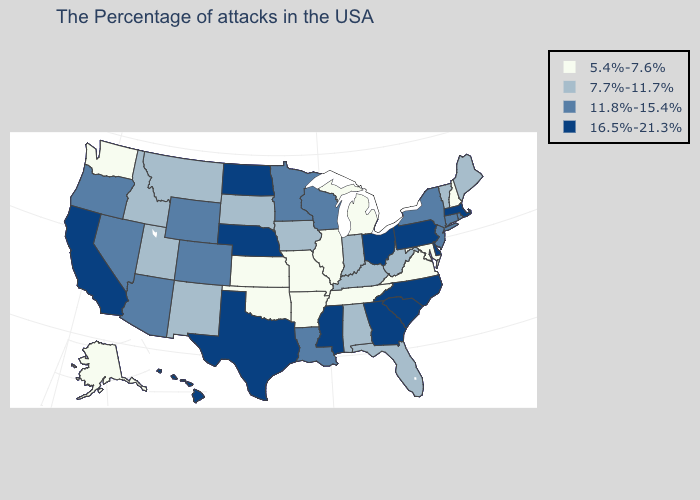Does Alaska have the lowest value in the West?
Give a very brief answer. Yes. Does the first symbol in the legend represent the smallest category?
Quick response, please. Yes. Name the states that have a value in the range 7.7%-11.7%?
Keep it brief. Maine, Vermont, West Virginia, Florida, Kentucky, Indiana, Alabama, Iowa, South Dakota, New Mexico, Utah, Montana, Idaho. Which states have the lowest value in the USA?
Short answer required. New Hampshire, Maryland, Virginia, Michigan, Tennessee, Illinois, Missouri, Arkansas, Kansas, Oklahoma, Washington, Alaska. Name the states that have a value in the range 11.8%-15.4%?
Answer briefly. Rhode Island, Connecticut, New York, New Jersey, Wisconsin, Louisiana, Minnesota, Wyoming, Colorado, Arizona, Nevada, Oregon. Does South Carolina have a lower value than Oklahoma?
Concise answer only. No. What is the value of Ohio?
Answer briefly. 16.5%-21.3%. What is the lowest value in the USA?
Be succinct. 5.4%-7.6%. Name the states that have a value in the range 16.5%-21.3%?
Concise answer only. Massachusetts, Delaware, Pennsylvania, North Carolina, South Carolina, Ohio, Georgia, Mississippi, Nebraska, Texas, North Dakota, California, Hawaii. Name the states that have a value in the range 5.4%-7.6%?
Concise answer only. New Hampshire, Maryland, Virginia, Michigan, Tennessee, Illinois, Missouri, Arkansas, Kansas, Oklahoma, Washington, Alaska. What is the value of California?
Quick response, please. 16.5%-21.3%. Does Oklahoma have a lower value than Illinois?
Give a very brief answer. No. What is the value of Delaware?
Quick response, please. 16.5%-21.3%. Among the states that border Kansas , which have the highest value?
Keep it brief. Nebraska. What is the value of Illinois?
Keep it brief. 5.4%-7.6%. 